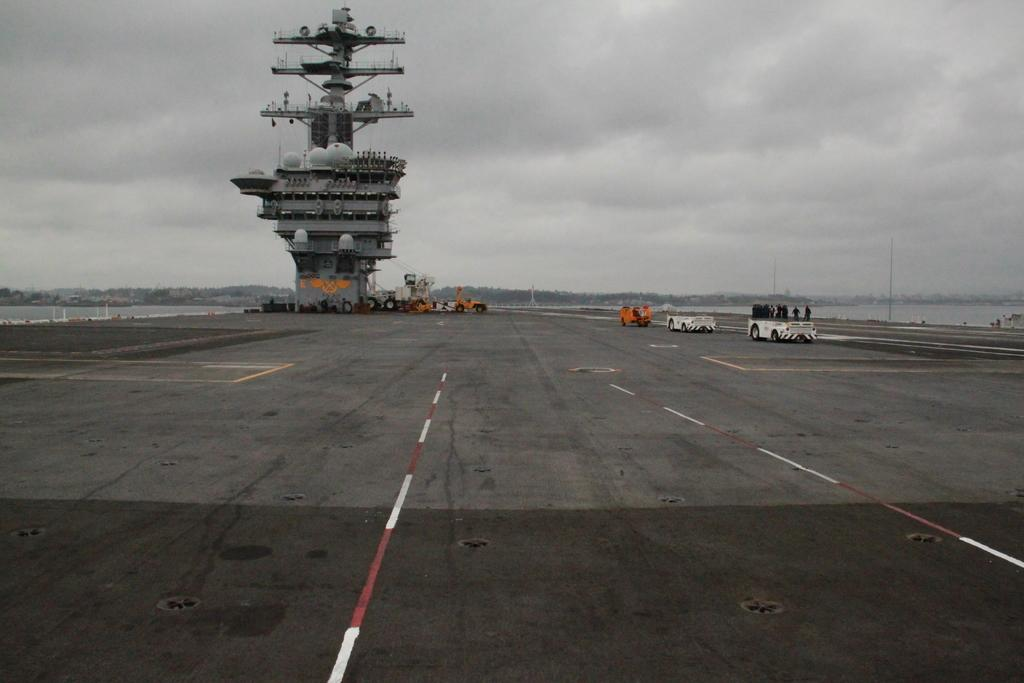What type of transportation can be seen on the road in the image? There are vehicles on the road in the image. What are the people in the image wearing? The people in the image are wearing clothes. What is the body of water in the image used for? There is a boat in the image, which suggests that the body of water is used for transportation or recreation. What are the tall, thin structures in the image? There are poles in the image. How would you describe the weather in the image? The sky is cloudy in the image. What is the name of the daughter of the person driving the vehicle in the image? There is no information about a daughter or any specific person driving the vehicle in the image. How does the drum aid in the digestion process of the people in the image? There is no drum or mention of digestion in the image. 